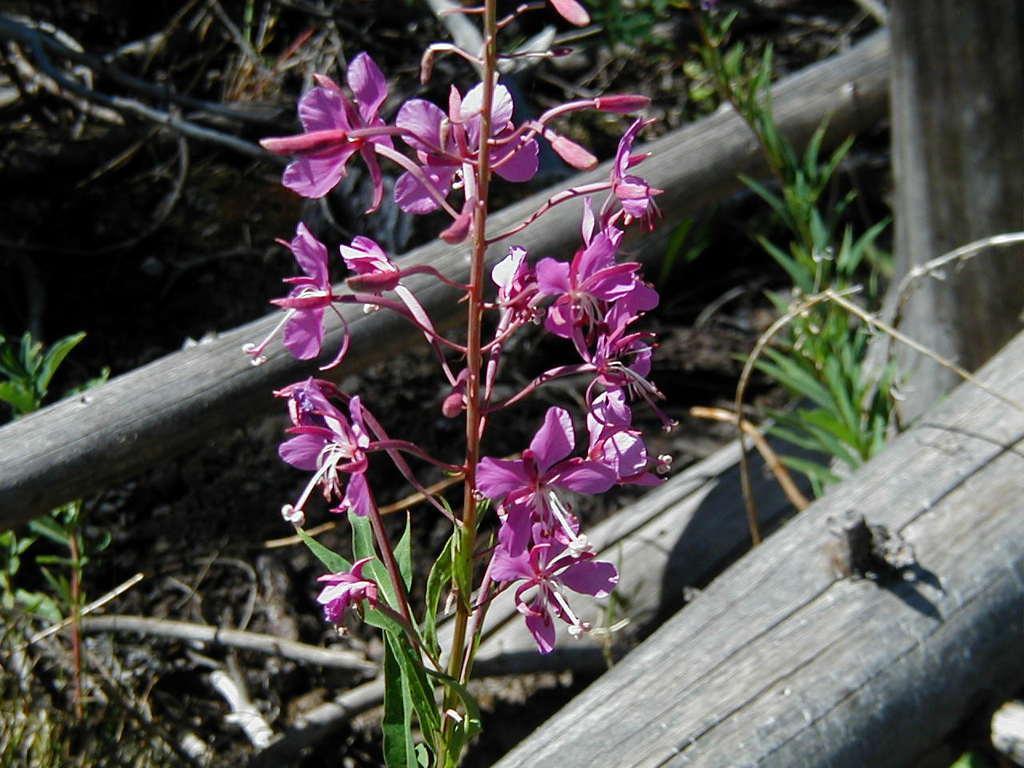Please provide a concise description of this image. In this image we can see flowers, plants, also we can see wooden poles. 